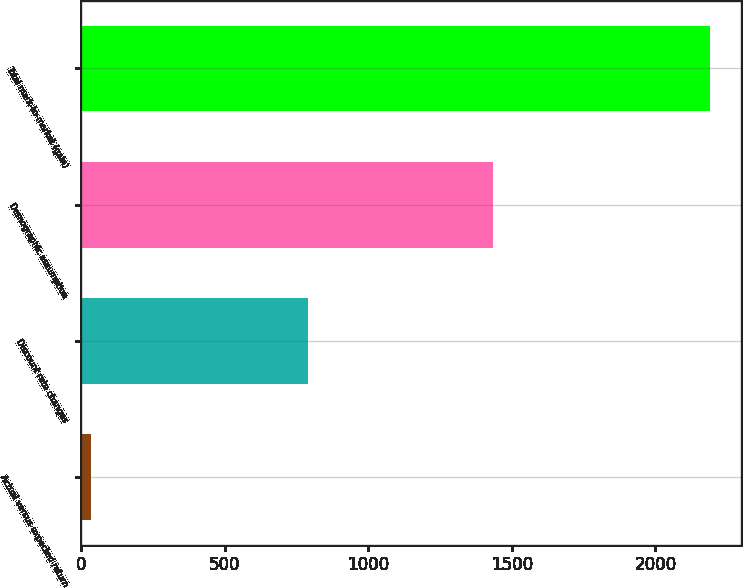Convert chart to OTSL. <chart><loc_0><loc_0><loc_500><loc_500><bar_chart><fcel>Actual versus expected return<fcel>Discount rate changes<fcel>Demographic assumption<fcel>Total mark-to-market (gain)<nl><fcel>35<fcel>791<fcel>1434<fcel>2190<nl></chart> 